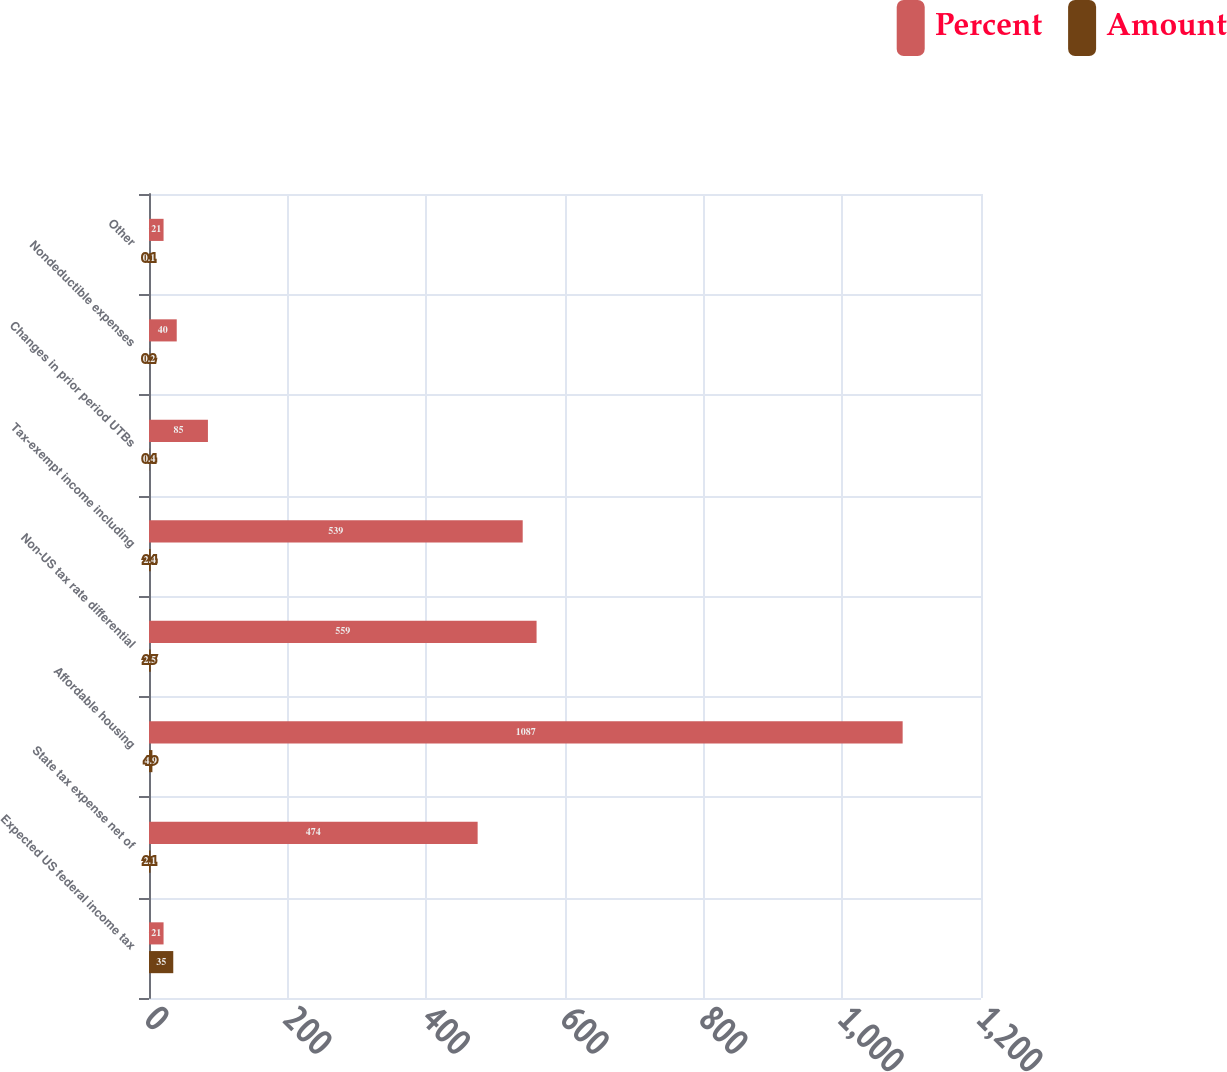Convert chart to OTSL. <chart><loc_0><loc_0><loc_500><loc_500><stacked_bar_chart><ecel><fcel>Expected US federal income tax<fcel>State tax expense net of<fcel>Affordable housing<fcel>Non-US tax rate differential<fcel>Tax-exempt income including<fcel>Changes in prior period UTBs<fcel>Nondeductible expenses<fcel>Other<nl><fcel>Percent<fcel>21<fcel>474<fcel>1087<fcel>559<fcel>539<fcel>85<fcel>40<fcel>21<nl><fcel>Amount<fcel>35<fcel>2.1<fcel>4.9<fcel>2.5<fcel>2.4<fcel>0.4<fcel>0.2<fcel>0.1<nl></chart> 